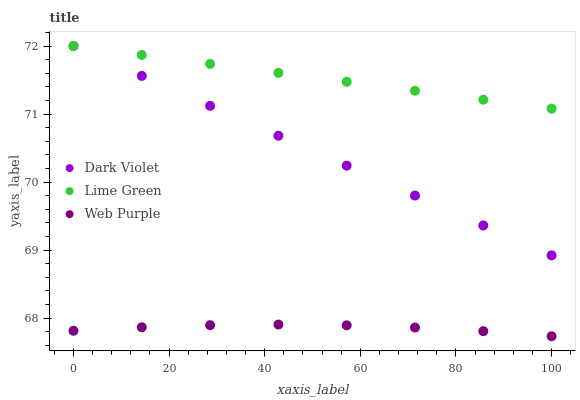Does Web Purple have the minimum area under the curve?
Answer yes or no. Yes. Does Lime Green have the maximum area under the curve?
Answer yes or no. Yes. Does Dark Violet have the minimum area under the curve?
Answer yes or no. No. Does Dark Violet have the maximum area under the curve?
Answer yes or no. No. Is Dark Violet the smoothest?
Answer yes or no. Yes. Is Web Purple the roughest?
Answer yes or no. Yes. Is Lime Green the smoothest?
Answer yes or no. No. Is Lime Green the roughest?
Answer yes or no. No. Does Web Purple have the lowest value?
Answer yes or no. Yes. Does Dark Violet have the lowest value?
Answer yes or no. No. Does Dark Violet have the highest value?
Answer yes or no. Yes. Is Web Purple less than Dark Violet?
Answer yes or no. Yes. Is Lime Green greater than Web Purple?
Answer yes or no. Yes. Does Lime Green intersect Dark Violet?
Answer yes or no. Yes. Is Lime Green less than Dark Violet?
Answer yes or no. No. Is Lime Green greater than Dark Violet?
Answer yes or no. No. Does Web Purple intersect Dark Violet?
Answer yes or no. No. 